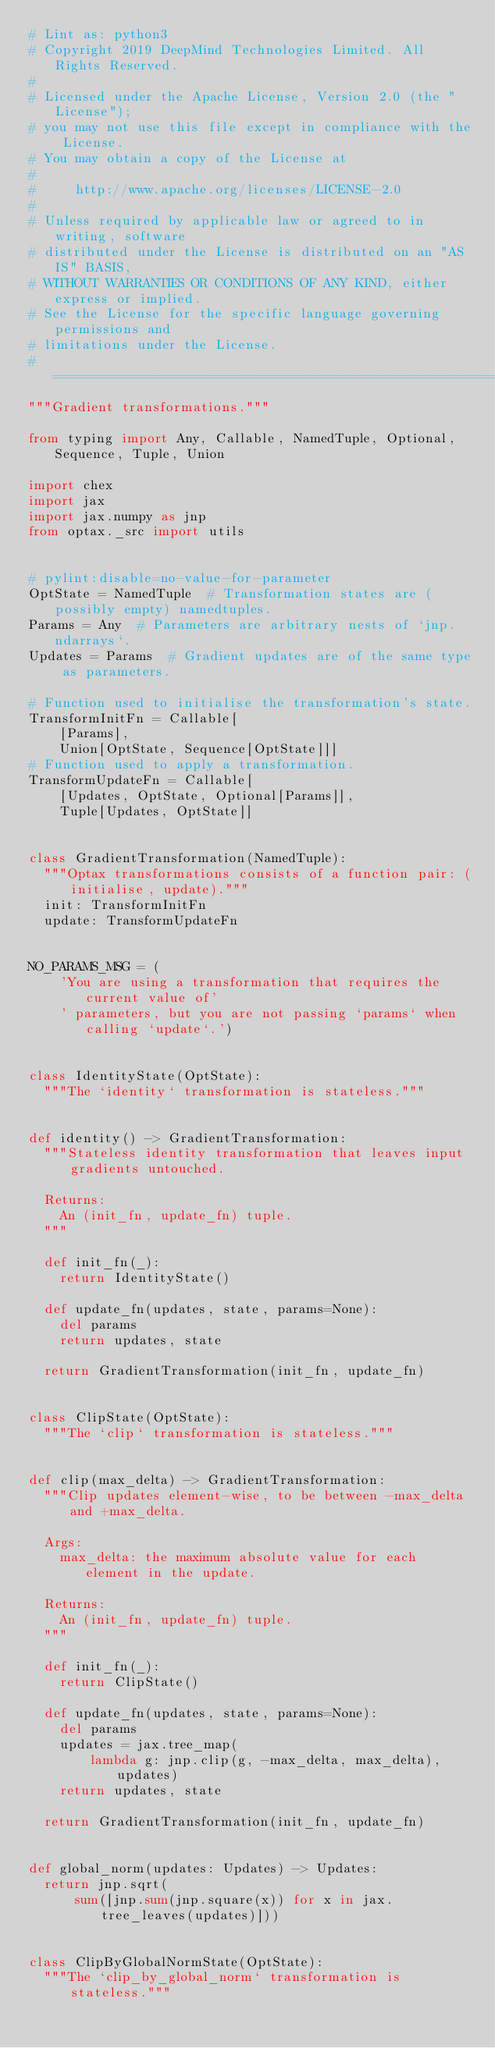<code> <loc_0><loc_0><loc_500><loc_500><_Python_># Lint as: python3
# Copyright 2019 DeepMind Technologies Limited. All Rights Reserved.
#
# Licensed under the Apache License, Version 2.0 (the "License");
# you may not use this file except in compliance with the License.
# You may obtain a copy of the License at
#
#     http://www.apache.org/licenses/LICENSE-2.0
#
# Unless required by applicable law or agreed to in writing, software
# distributed under the License is distributed on an "AS IS" BASIS,
# WITHOUT WARRANTIES OR CONDITIONS OF ANY KIND, either express or implied.
# See the License for the specific language governing permissions and
# limitations under the License.
# ==============================================================================
"""Gradient transformations."""

from typing import Any, Callable, NamedTuple, Optional, Sequence, Tuple, Union

import chex
import jax
import jax.numpy as jnp
from optax._src import utils


# pylint:disable=no-value-for-parameter
OptState = NamedTuple  # Transformation states are (possibly empty) namedtuples.
Params = Any  # Parameters are arbitrary nests of `jnp.ndarrays`.
Updates = Params  # Gradient updates are of the same type as parameters.

# Function used to initialise the transformation's state.
TransformInitFn = Callable[
    [Params],
    Union[OptState, Sequence[OptState]]]
# Function used to apply a transformation.
TransformUpdateFn = Callable[
    [Updates, OptState, Optional[Params]],
    Tuple[Updates, OptState]]


class GradientTransformation(NamedTuple):
  """Optax transformations consists of a function pair: (initialise, update)."""
  init: TransformInitFn
  update: TransformUpdateFn


NO_PARAMS_MSG = (
    'You are using a transformation that requires the current value of'
    ' parameters, but you are not passing `params` when calling `update`.')


class IdentityState(OptState):
  """The `identity` transformation is stateless."""


def identity() -> GradientTransformation:
  """Stateless identity transformation that leaves input gradients untouched.

  Returns:
    An (init_fn, update_fn) tuple.
  """

  def init_fn(_):
    return IdentityState()

  def update_fn(updates, state, params=None):
    del params
    return updates, state

  return GradientTransformation(init_fn, update_fn)


class ClipState(OptState):
  """The `clip` transformation is stateless."""


def clip(max_delta) -> GradientTransformation:
  """Clip updates element-wise, to be between -max_delta and +max_delta.

  Args:
    max_delta: the maximum absolute value for each element in the update.

  Returns:
    An (init_fn, update_fn) tuple.
  """

  def init_fn(_):
    return ClipState()

  def update_fn(updates, state, params=None):
    del params
    updates = jax.tree_map(
        lambda g: jnp.clip(g, -max_delta, max_delta), updates)
    return updates, state

  return GradientTransformation(init_fn, update_fn)


def global_norm(updates: Updates) -> Updates:
  return jnp.sqrt(
      sum([jnp.sum(jnp.square(x)) for x in jax.tree_leaves(updates)]))


class ClipByGlobalNormState(OptState):
  """The `clip_by_global_norm` transformation is stateless."""

</code> 